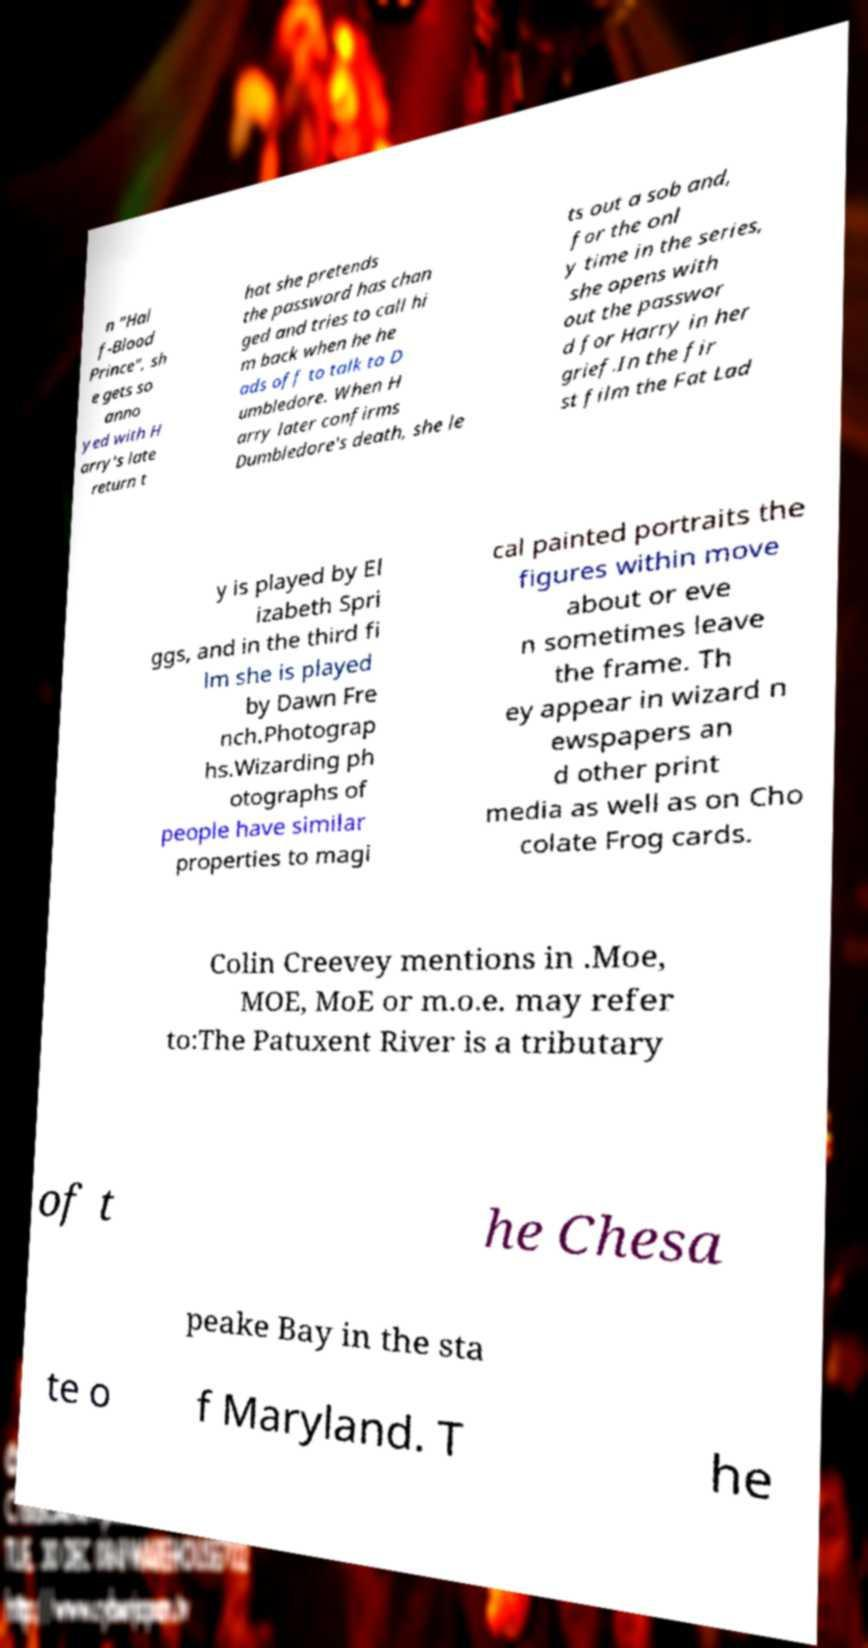For documentation purposes, I need the text within this image transcribed. Could you provide that? n "Hal f-Blood Prince", sh e gets so anno yed with H arry's late return t hat she pretends the password has chan ged and tries to call hi m back when he he ads off to talk to D umbledore. When H arry later confirms Dumbledore's death, she le ts out a sob and, for the onl y time in the series, she opens with out the passwor d for Harry in her grief.In the fir st film the Fat Lad y is played by El izabeth Spri ggs, and in the third fi lm she is played by Dawn Fre nch.Photograp hs.Wizarding ph otographs of people have similar properties to magi cal painted portraits the figures within move about or eve n sometimes leave the frame. Th ey appear in wizard n ewspapers an d other print media as well as on Cho colate Frog cards. Colin Creevey mentions in .Moe, MOE, MoE or m.o.e. may refer to:The Patuxent River is a tributary of t he Chesa peake Bay in the sta te o f Maryland. T he 